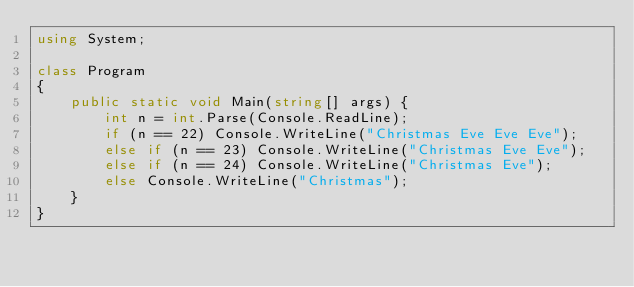Convert code to text. <code><loc_0><loc_0><loc_500><loc_500><_C#_>using System;

class Program
{
    public static void Main(string[] args) {
        int n = int.Parse(Console.ReadLine);
        if (n == 22) Console.WriteLine("Christmas Eve Eve Eve");
        else if (n == 23) Console.WriteLine("Christmas Eve Eve");
        else if (n == 24) Console.WriteLine("Christmas Eve");
        else Console.WriteLine("Christmas");
    }
}</code> 